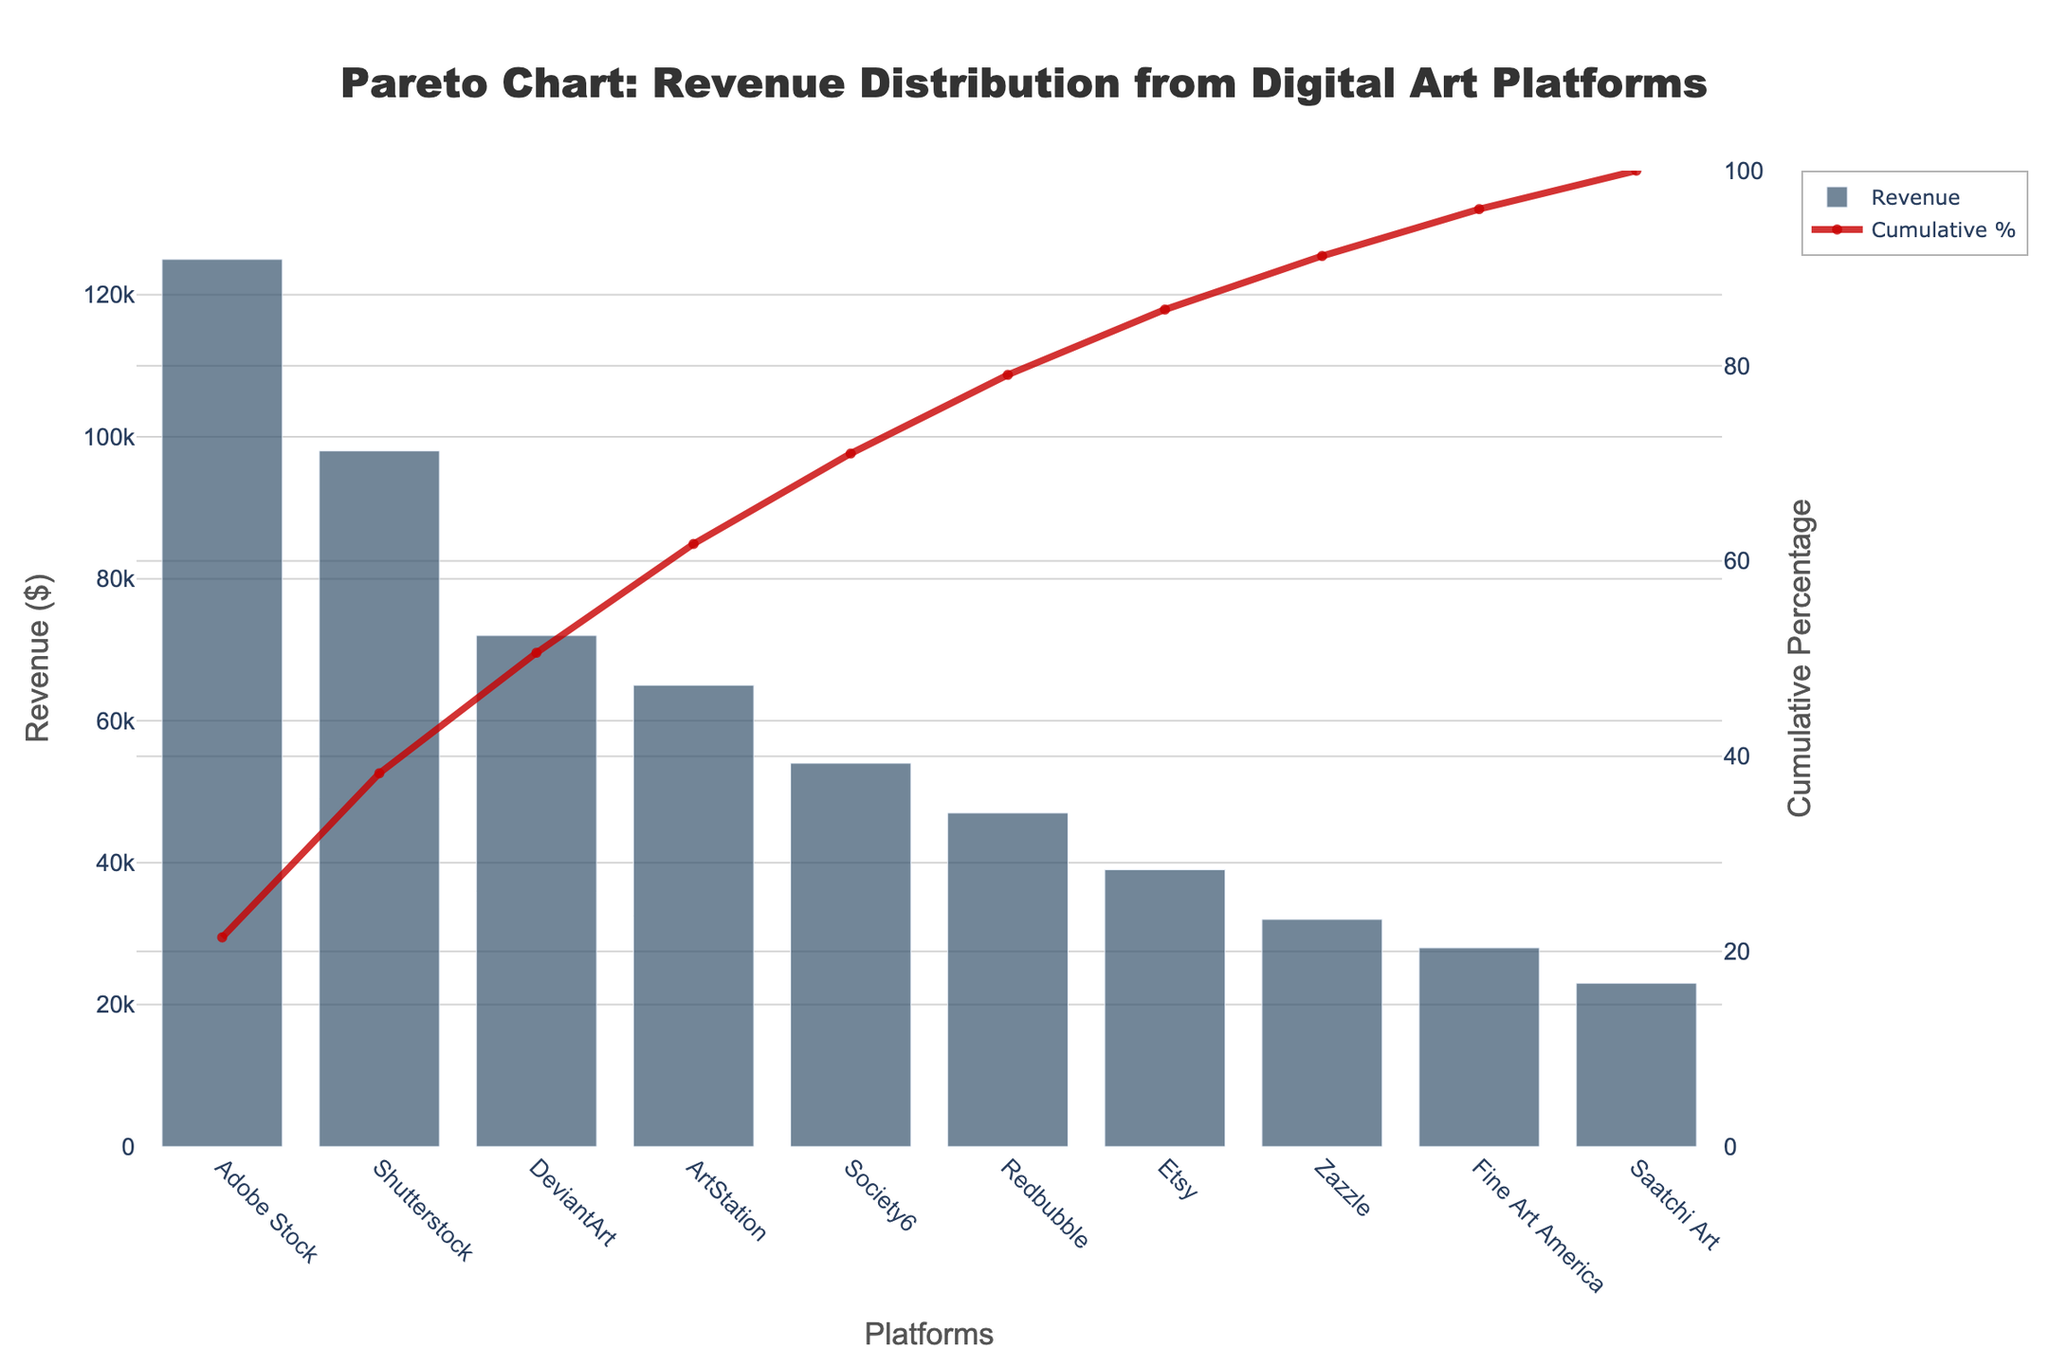what is the title of the plot? The title of the plot is located at the top and centered. It reads "Pareto Chart: Revenue Distribution from Digital Art Platforms."
Answer: Pareto Chart: Revenue Distribution from Digital Art Platforms which platform has the highest revenue? The platform with the highest revenue can be identified by looking at the tallest bar in the chart. This bar corresponds to Adobe Stock.
Answer: Adobe Stock what is the revenue of Society6? By finding the bar labeled "Society6" on the x-axis and referring to its height on the y-axis, we can determine that the revenue for Society6 is $54,000.
Answer: $54,000 what cumulative percentage does DeviantArt contribute? The cumulative percentage line plotted as a secondary y-axis can be checked against the label for DeviantArt. It falls slightly above 60%.
Answer: Approximately 61% how many platforms contribute to approximately 80% of the total revenue? We can find out how many platforms contribute to approximately 80% by following the cumulative percentage line until it reaches about 80% and counting the number of bars up to that point. In this chart, it is Adobe Stock, Shutterstock, DeviantArt, and ArtStation.
Answer: 4 platforms what is the combined revenue of the top three platforms? The top three platforms by revenue are Adobe Stock ($125,000), Shutterstock ($98,000), and DeviantArt ($72,000). Summing these, we get $125,000 + $98,000 + $72,000 = $295,000.
Answer: $295,000 which platform has the lowest revenue, and what's the amount? The platform with the lowest revenue can be identified as the shortest bar, which is Saatchi Art with $23,000.
Answer: Saatchi Art, $23,000 what difference in revenue exists between Zazzle and Etsy? The revenue for Zazzle is $32,000 and for Etsy is $39,000. The difference is $39,000 - $32,000 = $7,000.
Answer: $7,000 which platform appears fourth in contributing to the cumulative percentage of revenue? By following the cumulative percentage line, we can see that the fourth platform listed contributes ArtStation.
Answer: ArtStation what is the revenue percentage contribution of Redbubble? The revenue for Redbubble is $47,000. To find its percentage contribution, we calculate (47,000 / total revenue) * 100. The total revenue is $125,000 + $98,000 + $72,000 + $65,000 + $54,000 + $47,000 + $39,000 + $32,000 + $28,000 + $23,000 = $583,000. Therefore, (47,000 / 583,000) * 100 = 8.06%.
Answer: Approximately 8.06% 